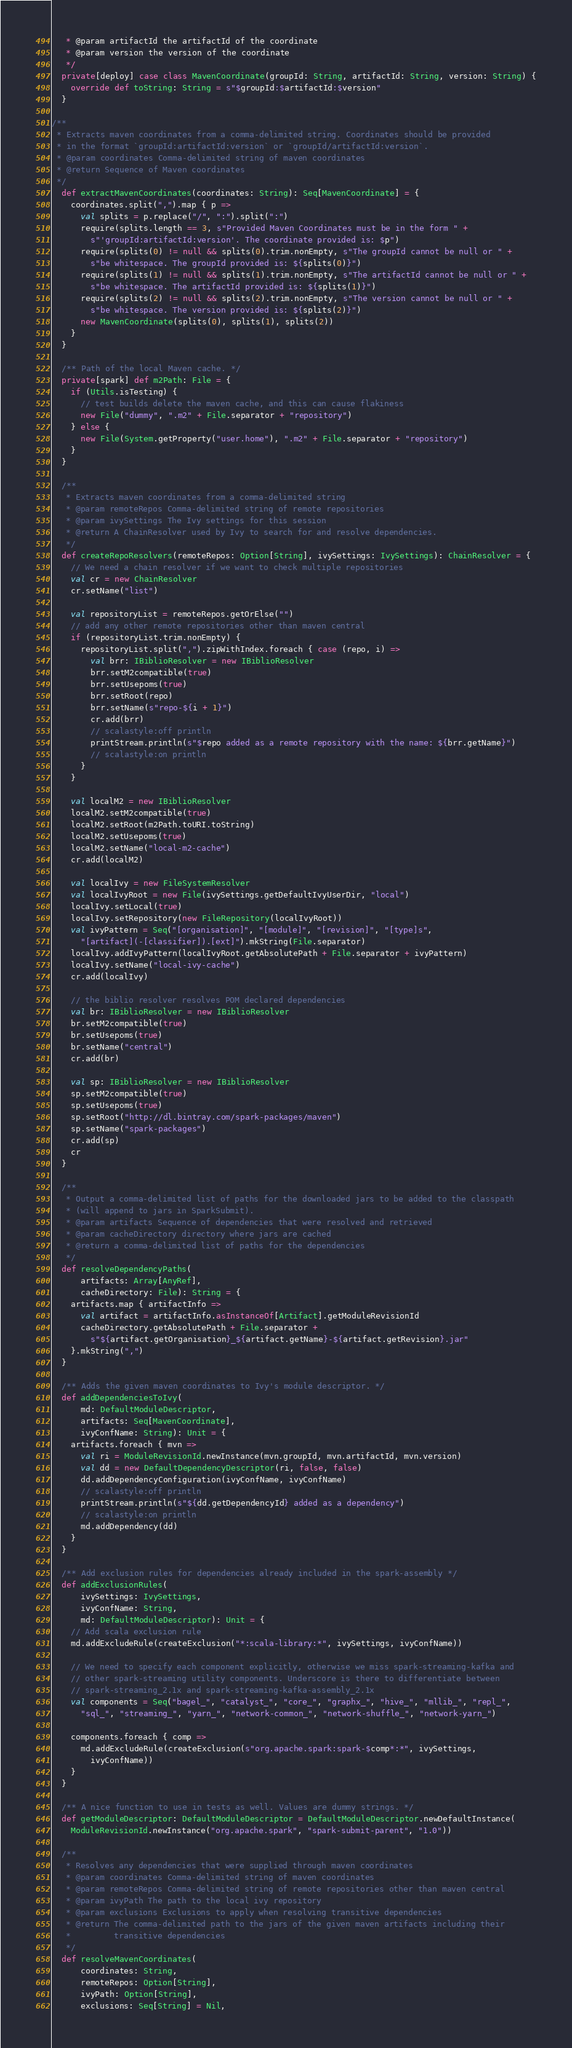Convert code to text. <code><loc_0><loc_0><loc_500><loc_500><_Scala_>   * @param artifactId the artifactId of the coordinate
   * @param version the version of the coordinate
   */
  private[deploy] case class MavenCoordinate(groupId: String, artifactId: String, version: String) {
    override def toString: String = s"$groupId:$artifactId:$version"
  }

/**
 * Extracts maven coordinates from a comma-delimited string. Coordinates should be provided
 * in the format `groupId:artifactId:version` or `groupId/artifactId:version`.
 * @param coordinates Comma-delimited string of maven coordinates
 * @return Sequence of Maven coordinates
 */
  def extractMavenCoordinates(coordinates: String): Seq[MavenCoordinate] = {
    coordinates.split(",").map { p =>
      val splits = p.replace("/", ":").split(":")
      require(splits.length == 3, s"Provided Maven Coordinates must be in the form " +
        s"'groupId:artifactId:version'. The coordinate provided is: $p")
      require(splits(0) != null && splits(0).trim.nonEmpty, s"The groupId cannot be null or " +
        s"be whitespace. The groupId provided is: ${splits(0)}")
      require(splits(1) != null && splits(1).trim.nonEmpty, s"The artifactId cannot be null or " +
        s"be whitespace. The artifactId provided is: ${splits(1)}")
      require(splits(2) != null && splits(2).trim.nonEmpty, s"The version cannot be null or " +
        s"be whitespace. The version provided is: ${splits(2)}")
      new MavenCoordinate(splits(0), splits(1), splits(2))
    }
  }

  /** Path of the local Maven cache. */
  private[spark] def m2Path: File = {
    if (Utils.isTesting) {
      // test builds delete the maven cache, and this can cause flakiness
      new File("dummy", ".m2" + File.separator + "repository")
    } else {
      new File(System.getProperty("user.home"), ".m2" + File.separator + "repository")
    }
  }

  /**
   * Extracts maven coordinates from a comma-delimited string
   * @param remoteRepos Comma-delimited string of remote repositories
   * @param ivySettings The Ivy settings for this session
   * @return A ChainResolver used by Ivy to search for and resolve dependencies.
   */
  def createRepoResolvers(remoteRepos: Option[String], ivySettings: IvySettings): ChainResolver = {
    // We need a chain resolver if we want to check multiple repositories
    val cr = new ChainResolver
    cr.setName("list")

    val repositoryList = remoteRepos.getOrElse("")
    // add any other remote repositories other than maven central
    if (repositoryList.trim.nonEmpty) {
      repositoryList.split(",").zipWithIndex.foreach { case (repo, i) =>
        val brr: IBiblioResolver = new IBiblioResolver
        brr.setM2compatible(true)
        brr.setUsepoms(true)
        brr.setRoot(repo)
        brr.setName(s"repo-${i + 1}")
        cr.add(brr)
        // scalastyle:off println
        printStream.println(s"$repo added as a remote repository with the name: ${brr.getName}")
        // scalastyle:on println
      }
    }

    val localM2 = new IBiblioResolver
    localM2.setM2compatible(true)
    localM2.setRoot(m2Path.toURI.toString)
    localM2.setUsepoms(true)
    localM2.setName("local-m2-cache")
    cr.add(localM2)

    val localIvy = new FileSystemResolver
    val localIvyRoot = new File(ivySettings.getDefaultIvyUserDir, "local")
    localIvy.setLocal(true)
    localIvy.setRepository(new FileRepository(localIvyRoot))
    val ivyPattern = Seq("[organisation]", "[module]", "[revision]", "[type]s",
      "[artifact](-[classifier]).[ext]").mkString(File.separator)
    localIvy.addIvyPattern(localIvyRoot.getAbsolutePath + File.separator + ivyPattern)
    localIvy.setName("local-ivy-cache")
    cr.add(localIvy)

    // the biblio resolver resolves POM declared dependencies
    val br: IBiblioResolver = new IBiblioResolver
    br.setM2compatible(true)
    br.setUsepoms(true)
    br.setName("central")
    cr.add(br)

    val sp: IBiblioResolver = new IBiblioResolver
    sp.setM2compatible(true)
    sp.setUsepoms(true)
    sp.setRoot("http://dl.bintray.com/spark-packages/maven")
    sp.setName("spark-packages")
    cr.add(sp)
    cr
  }

  /**
   * Output a comma-delimited list of paths for the downloaded jars to be added to the classpath
   * (will append to jars in SparkSubmit).
   * @param artifacts Sequence of dependencies that were resolved and retrieved
   * @param cacheDirectory directory where jars are cached
   * @return a comma-delimited list of paths for the dependencies
   */
  def resolveDependencyPaths(
      artifacts: Array[AnyRef],
      cacheDirectory: File): String = {
    artifacts.map { artifactInfo =>
      val artifact = artifactInfo.asInstanceOf[Artifact].getModuleRevisionId
      cacheDirectory.getAbsolutePath + File.separator +
        s"${artifact.getOrganisation}_${artifact.getName}-${artifact.getRevision}.jar"
    }.mkString(",")
  }

  /** Adds the given maven coordinates to Ivy's module descriptor. */
  def addDependenciesToIvy(
      md: DefaultModuleDescriptor,
      artifacts: Seq[MavenCoordinate],
      ivyConfName: String): Unit = {
    artifacts.foreach { mvn =>
      val ri = ModuleRevisionId.newInstance(mvn.groupId, mvn.artifactId, mvn.version)
      val dd = new DefaultDependencyDescriptor(ri, false, false)
      dd.addDependencyConfiguration(ivyConfName, ivyConfName)
      // scalastyle:off println
      printStream.println(s"${dd.getDependencyId} added as a dependency")
      // scalastyle:on println
      md.addDependency(dd)
    }
  }

  /** Add exclusion rules for dependencies already included in the spark-assembly */
  def addExclusionRules(
      ivySettings: IvySettings,
      ivyConfName: String,
      md: DefaultModuleDescriptor): Unit = {
    // Add scala exclusion rule
    md.addExcludeRule(createExclusion("*:scala-library:*", ivySettings, ivyConfName))

    // We need to specify each component explicitly, otherwise we miss spark-streaming-kafka and
    // other spark-streaming utility components. Underscore is there to differentiate between
    // spark-streaming_2.1x and spark-streaming-kafka-assembly_2.1x
    val components = Seq("bagel_", "catalyst_", "core_", "graphx_", "hive_", "mllib_", "repl_",
      "sql_", "streaming_", "yarn_", "network-common_", "network-shuffle_", "network-yarn_")

    components.foreach { comp =>
      md.addExcludeRule(createExclusion(s"org.apache.spark:spark-$comp*:*", ivySettings,
        ivyConfName))
    }
  }

  /** A nice function to use in tests as well. Values are dummy strings. */
  def getModuleDescriptor: DefaultModuleDescriptor = DefaultModuleDescriptor.newDefaultInstance(
    ModuleRevisionId.newInstance("org.apache.spark", "spark-submit-parent", "1.0"))

  /**
   * Resolves any dependencies that were supplied through maven coordinates
   * @param coordinates Comma-delimited string of maven coordinates
   * @param remoteRepos Comma-delimited string of remote repositories other than maven central
   * @param ivyPath The path to the local ivy repository
   * @param exclusions Exclusions to apply when resolving transitive dependencies
   * @return The comma-delimited path to the jars of the given maven artifacts including their
   *         transitive dependencies
   */
  def resolveMavenCoordinates(
      coordinates: String,
      remoteRepos: Option[String],
      ivyPath: Option[String],
      exclusions: Seq[String] = Nil,</code> 